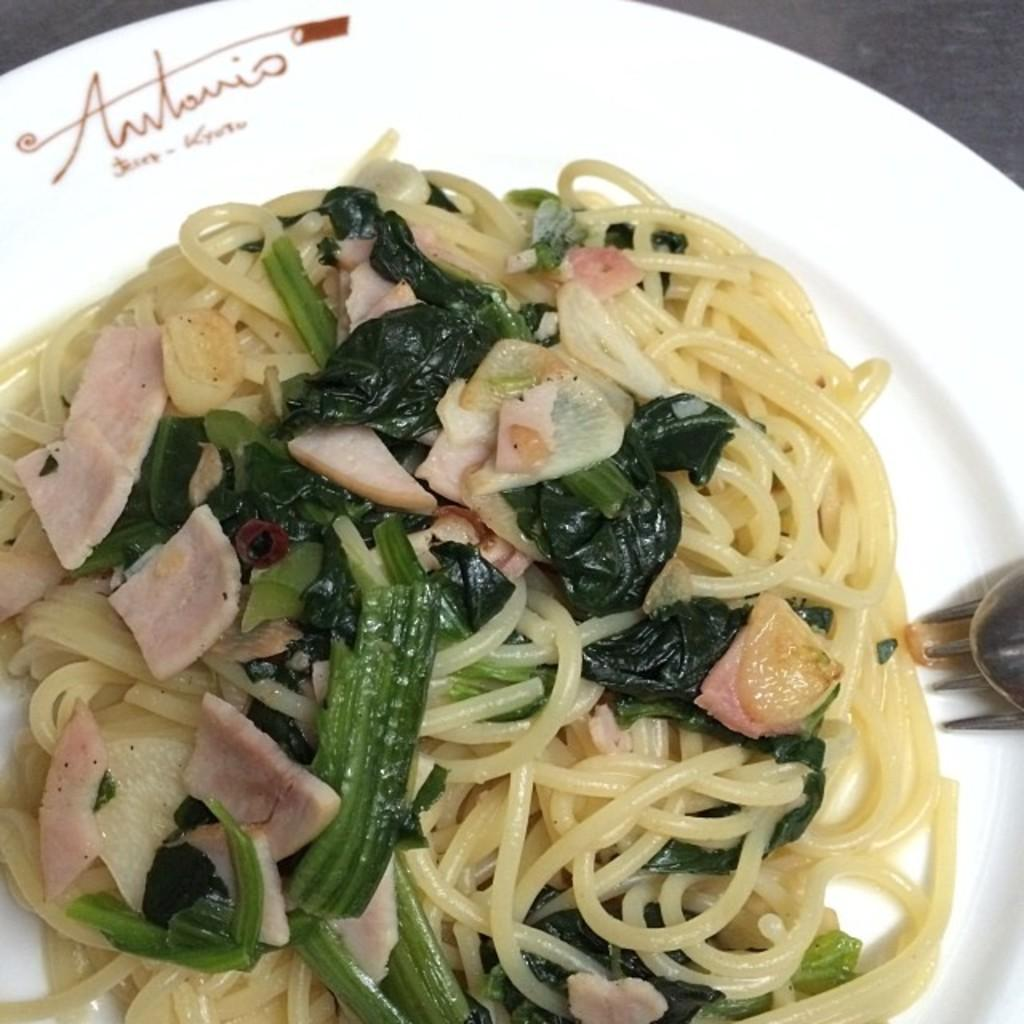What object is present in the image that is typically used for serving or eating food? There is a plate in the image. What is on the plate in the image? There is food on the plate. What utensils are visible in the image? There is a fork and a spoon in the image. Where is the sink located in the image? There is no sink present in the image. What type of glove can be seen being used to eat the food on the plate? There is no glove present in the image, and gloves are not typically used for eating food. 